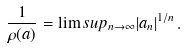Convert formula to latex. <formula><loc_0><loc_0><loc_500><loc_500>\frac { 1 } { \rho ( a ) } = \lim s u p _ { n \rightarrow \infty } | a _ { n } | ^ { 1 / n } \, .</formula> 